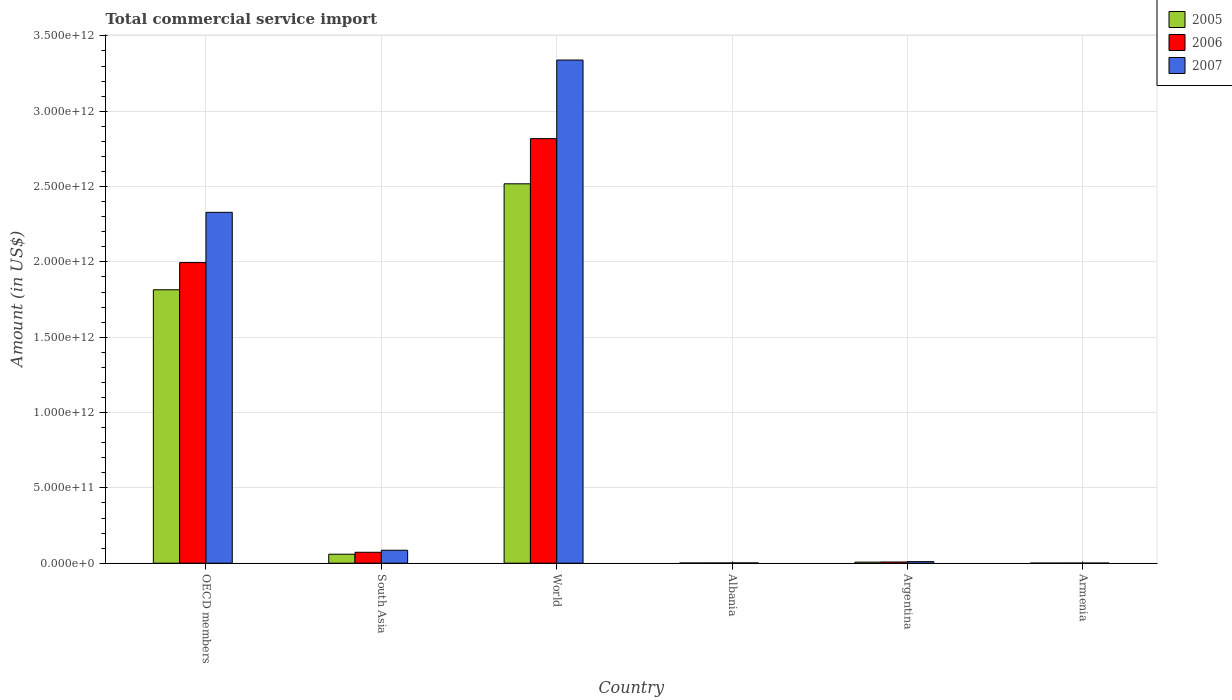How many different coloured bars are there?
Your answer should be compact. 3. How many groups of bars are there?
Keep it short and to the point. 6. Are the number of bars on each tick of the X-axis equal?
Provide a succinct answer. Yes. How many bars are there on the 1st tick from the left?
Provide a succinct answer. 3. How many bars are there on the 1st tick from the right?
Offer a very short reply. 3. What is the label of the 3rd group of bars from the left?
Make the answer very short. World. What is the total commercial service import in 2005 in South Asia?
Provide a succinct answer. 5.96e+1. Across all countries, what is the maximum total commercial service import in 2005?
Provide a succinct answer. 2.52e+12. Across all countries, what is the minimum total commercial service import in 2007?
Offer a very short reply. 8.64e+08. In which country was the total commercial service import in 2005 maximum?
Ensure brevity in your answer.  World. In which country was the total commercial service import in 2005 minimum?
Provide a succinct answer. Armenia. What is the total total commercial service import in 2006 in the graph?
Provide a short and direct response. 4.90e+12. What is the difference between the total commercial service import in 2006 in Albania and that in World?
Provide a succinct answer. -2.82e+12. What is the difference between the total commercial service import in 2005 in OECD members and the total commercial service import in 2007 in South Asia?
Offer a very short reply. 1.73e+12. What is the average total commercial service import in 2007 per country?
Your response must be concise. 9.61e+11. What is the difference between the total commercial service import of/in 2006 and total commercial service import of/in 2005 in World?
Offer a very short reply. 3.00e+11. In how many countries, is the total commercial service import in 2005 greater than 2000000000000 US$?
Your answer should be very brief. 1. What is the ratio of the total commercial service import in 2007 in Argentina to that in South Asia?
Make the answer very short. 0.12. Is the total commercial service import in 2005 in Argentina less than that in OECD members?
Offer a very short reply. Yes. Is the difference between the total commercial service import in 2006 in Albania and World greater than the difference between the total commercial service import in 2005 in Albania and World?
Offer a very short reply. No. What is the difference between the highest and the second highest total commercial service import in 2005?
Keep it short and to the point. -7.03e+11. What is the difference between the highest and the lowest total commercial service import in 2005?
Your answer should be very brief. 2.52e+12. In how many countries, is the total commercial service import in 2006 greater than the average total commercial service import in 2006 taken over all countries?
Your answer should be very brief. 2. Is the sum of the total commercial service import in 2007 in Albania and South Asia greater than the maximum total commercial service import in 2006 across all countries?
Make the answer very short. No. What does the 1st bar from the right in OECD members represents?
Provide a succinct answer. 2007. Is it the case that in every country, the sum of the total commercial service import in 2007 and total commercial service import in 2005 is greater than the total commercial service import in 2006?
Offer a terse response. Yes. Are all the bars in the graph horizontal?
Offer a terse response. No. What is the difference between two consecutive major ticks on the Y-axis?
Your answer should be compact. 5.00e+11. Are the values on the major ticks of Y-axis written in scientific E-notation?
Your answer should be compact. Yes. Does the graph contain any zero values?
Your answer should be compact. No. Where does the legend appear in the graph?
Make the answer very short. Top right. How are the legend labels stacked?
Your response must be concise. Vertical. What is the title of the graph?
Offer a terse response. Total commercial service import. What is the label or title of the Y-axis?
Offer a terse response. Amount (in US$). What is the Amount (in US$) in 2005 in OECD members?
Offer a very short reply. 1.81e+12. What is the Amount (in US$) in 2006 in OECD members?
Your answer should be compact. 2.00e+12. What is the Amount (in US$) of 2007 in OECD members?
Ensure brevity in your answer.  2.33e+12. What is the Amount (in US$) of 2005 in South Asia?
Keep it short and to the point. 5.96e+1. What is the Amount (in US$) of 2006 in South Asia?
Give a very brief answer. 7.25e+1. What is the Amount (in US$) of 2007 in South Asia?
Your answer should be compact. 8.60e+1. What is the Amount (in US$) in 2005 in World?
Offer a terse response. 2.52e+12. What is the Amount (in US$) in 2006 in World?
Give a very brief answer. 2.82e+12. What is the Amount (in US$) in 2007 in World?
Your response must be concise. 3.34e+12. What is the Amount (in US$) of 2005 in Albania?
Give a very brief answer. 1.32e+09. What is the Amount (in US$) of 2006 in Albania?
Provide a succinct answer. 1.54e+09. What is the Amount (in US$) of 2007 in Albania?
Your answer should be compact. 1.89e+09. What is the Amount (in US$) of 2005 in Argentina?
Offer a very short reply. 7.24e+09. What is the Amount (in US$) of 2006 in Argentina?
Your response must be concise. 8.10e+09. What is the Amount (in US$) in 2007 in Argentina?
Offer a very short reply. 1.04e+1. What is the Amount (in US$) in 2005 in Armenia?
Ensure brevity in your answer.  5.61e+08. What is the Amount (in US$) of 2006 in Armenia?
Give a very brief answer. 6.62e+08. What is the Amount (in US$) of 2007 in Armenia?
Give a very brief answer. 8.64e+08. Across all countries, what is the maximum Amount (in US$) of 2005?
Your answer should be very brief. 2.52e+12. Across all countries, what is the maximum Amount (in US$) in 2006?
Ensure brevity in your answer.  2.82e+12. Across all countries, what is the maximum Amount (in US$) of 2007?
Give a very brief answer. 3.34e+12. Across all countries, what is the minimum Amount (in US$) in 2005?
Your response must be concise. 5.61e+08. Across all countries, what is the minimum Amount (in US$) in 2006?
Offer a terse response. 6.62e+08. Across all countries, what is the minimum Amount (in US$) in 2007?
Ensure brevity in your answer.  8.64e+08. What is the total Amount (in US$) in 2005 in the graph?
Your response must be concise. 4.40e+12. What is the total Amount (in US$) in 2006 in the graph?
Your answer should be compact. 4.90e+12. What is the total Amount (in US$) in 2007 in the graph?
Offer a very short reply. 5.77e+12. What is the difference between the Amount (in US$) in 2005 in OECD members and that in South Asia?
Ensure brevity in your answer.  1.76e+12. What is the difference between the Amount (in US$) of 2006 in OECD members and that in South Asia?
Make the answer very short. 1.92e+12. What is the difference between the Amount (in US$) in 2007 in OECD members and that in South Asia?
Give a very brief answer. 2.24e+12. What is the difference between the Amount (in US$) of 2005 in OECD members and that in World?
Provide a succinct answer. -7.03e+11. What is the difference between the Amount (in US$) of 2006 in OECD members and that in World?
Ensure brevity in your answer.  -8.23e+11. What is the difference between the Amount (in US$) in 2007 in OECD members and that in World?
Your response must be concise. -1.01e+12. What is the difference between the Amount (in US$) of 2005 in OECD members and that in Albania?
Offer a very short reply. 1.81e+12. What is the difference between the Amount (in US$) of 2006 in OECD members and that in Albania?
Give a very brief answer. 1.99e+12. What is the difference between the Amount (in US$) of 2007 in OECD members and that in Albania?
Provide a short and direct response. 2.33e+12. What is the difference between the Amount (in US$) of 2005 in OECD members and that in Argentina?
Offer a very short reply. 1.81e+12. What is the difference between the Amount (in US$) of 2006 in OECD members and that in Argentina?
Your response must be concise. 1.99e+12. What is the difference between the Amount (in US$) of 2007 in OECD members and that in Argentina?
Provide a succinct answer. 2.32e+12. What is the difference between the Amount (in US$) in 2005 in OECD members and that in Armenia?
Your answer should be compact. 1.81e+12. What is the difference between the Amount (in US$) in 2006 in OECD members and that in Armenia?
Provide a short and direct response. 1.99e+12. What is the difference between the Amount (in US$) in 2007 in OECD members and that in Armenia?
Your answer should be very brief. 2.33e+12. What is the difference between the Amount (in US$) of 2005 in South Asia and that in World?
Offer a terse response. -2.46e+12. What is the difference between the Amount (in US$) of 2006 in South Asia and that in World?
Your response must be concise. -2.75e+12. What is the difference between the Amount (in US$) in 2007 in South Asia and that in World?
Your answer should be very brief. -3.25e+12. What is the difference between the Amount (in US$) of 2005 in South Asia and that in Albania?
Offer a very short reply. 5.83e+1. What is the difference between the Amount (in US$) of 2006 in South Asia and that in Albania?
Make the answer very short. 7.10e+1. What is the difference between the Amount (in US$) in 2007 in South Asia and that in Albania?
Offer a terse response. 8.41e+1. What is the difference between the Amount (in US$) of 2005 in South Asia and that in Argentina?
Keep it short and to the point. 5.24e+1. What is the difference between the Amount (in US$) in 2006 in South Asia and that in Argentina?
Give a very brief answer. 6.44e+1. What is the difference between the Amount (in US$) of 2007 in South Asia and that in Argentina?
Offer a terse response. 7.56e+1. What is the difference between the Amount (in US$) in 2005 in South Asia and that in Armenia?
Your answer should be very brief. 5.91e+1. What is the difference between the Amount (in US$) in 2006 in South Asia and that in Armenia?
Your response must be concise. 7.19e+1. What is the difference between the Amount (in US$) in 2007 in South Asia and that in Armenia?
Your answer should be very brief. 8.51e+1. What is the difference between the Amount (in US$) of 2005 in World and that in Albania?
Keep it short and to the point. 2.52e+12. What is the difference between the Amount (in US$) in 2006 in World and that in Albania?
Make the answer very short. 2.82e+12. What is the difference between the Amount (in US$) in 2007 in World and that in Albania?
Make the answer very short. 3.34e+12. What is the difference between the Amount (in US$) in 2005 in World and that in Argentina?
Make the answer very short. 2.51e+12. What is the difference between the Amount (in US$) in 2006 in World and that in Argentina?
Give a very brief answer. 2.81e+12. What is the difference between the Amount (in US$) of 2007 in World and that in Argentina?
Ensure brevity in your answer.  3.33e+12. What is the difference between the Amount (in US$) in 2005 in World and that in Armenia?
Ensure brevity in your answer.  2.52e+12. What is the difference between the Amount (in US$) of 2006 in World and that in Armenia?
Your answer should be compact. 2.82e+12. What is the difference between the Amount (in US$) in 2007 in World and that in Armenia?
Keep it short and to the point. 3.34e+12. What is the difference between the Amount (in US$) of 2005 in Albania and that in Argentina?
Offer a terse response. -5.92e+09. What is the difference between the Amount (in US$) of 2006 in Albania and that in Argentina?
Your answer should be compact. -6.56e+09. What is the difference between the Amount (in US$) of 2007 in Albania and that in Argentina?
Ensure brevity in your answer.  -8.50e+09. What is the difference between the Amount (in US$) in 2005 in Albania and that in Armenia?
Give a very brief answer. 7.56e+08. What is the difference between the Amount (in US$) in 2006 in Albania and that in Armenia?
Keep it short and to the point. 8.79e+08. What is the difference between the Amount (in US$) in 2007 in Albania and that in Armenia?
Ensure brevity in your answer.  1.03e+09. What is the difference between the Amount (in US$) of 2005 in Argentina and that in Armenia?
Offer a very short reply. 6.67e+09. What is the difference between the Amount (in US$) in 2006 in Argentina and that in Armenia?
Your response must be concise. 7.44e+09. What is the difference between the Amount (in US$) in 2007 in Argentina and that in Armenia?
Your response must be concise. 9.53e+09. What is the difference between the Amount (in US$) in 2005 in OECD members and the Amount (in US$) in 2006 in South Asia?
Your response must be concise. 1.74e+12. What is the difference between the Amount (in US$) of 2005 in OECD members and the Amount (in US$) of 2007 in South Asia?
Offer a very short reply. 1.73e+12. What is the difference between the Amount (in US$) of 2006 in OECD members and the Amount (in US$) of 2007 in South Asia?
Your answer should be very brief. 1.91e+12. What is the difference between the Amount (in US$) of 2005 in OECD members and the Amount (in US$) of 2006 in World?
Give a very brief answer. -1.00e+12. What is the difference between the Amount (in US$) of 2005 in OECD members and the Amount (in US$) of 2007 in World?
Keep it short and to the point. -1.52e+12. What is the difference between the Amount (in US$) of 2006 in OECD members and the Amount (in US$) of 2007 in World?
Provide a succinct answer. -1.34e+12. What is the difference between the Amount (in US$) in 2005 in OECD members and the Amount (in US$) in 2006 in Albania?
Your response must be concise. 1.81e+12. What is the difference between the Amount (in US$) in 2005 in OECD members and the Amount (in US$) in 2007 in Albania?
Your response must be concise. 1.81e+12. What is the difference between the Amount (in US$) of 2006 in OECD members and the Amount (in US$) of 2007 in Albania?
Give a very brief answer. 1.99e+12. What is the difference between the Amount (in US$) in 2005 in OECD members and the Amount (in US$) in 2006 in Argentina?
Your response must be concise. 1.81e+12. What is the difference between the Amount (in US$) of 2005 in OECD members and the Amount (in US$) of 2007 in Argentina?
Offer a very short reply. 1.80e+12. What is the difference between the Amount (in US$) in 2006 in OECD members and the Amount (in US$) in 2007 in Argentina?
Your response must be concise. 1.99e+12. What is the difference between the Amount (in US$) of 2005 in OECD members and the Amount (in US$) of 2006 in Armenia?
Your answer should be compact. 1.81e+12. What is the difference between the Amount (in US$) in 2005 in OECD members and the Amount (in US$) in 2007 in Armenia?
Provide a succinct answer. 1.81e+12. What is the difference between the Amount (in US$) in 2006 in OECD members and the Amount (in US$) in 2007 in Armenia?
Offer a very short reply. 1.99e+12. What is the difference between the Amount (in US$) of 2005 in South Asia and the Amount (in US$) of 2006 in World?
Make the answer very short. -2.76e+12. What is the difference between the Amount (in US$) of 2005 in South Asia and the Amount (in US$) of 2007 in World?
Offer a terse response. -3.28e+12. What is the difference between the Amount (in US$) of 2006 in South Asia and the Amount (in US$) of 2007 in World?
Offer a terse response. -3.27e+12. What is the difference between the Amount (in US$) in 2005 in South Asia and the Amount (in US$) in 2006 in Albania?
Keep it short and to the point. 5.81e+1. What is the difference between the Amount (in US$) in 2005 in South Asia and the Amount (in US$) in 2007 in Albania?
Ensure brevity in your answer.  5.77e+1. What is the difference between the Amount (in US$) of 2006 in South Asia and the Amount (in US$) of 2007 in Albania?
Keep it short and to the point. 7.06e+1. What is the difference between the Amount (in US$) in 2005 in South Asia and the Amount (in US$) in 2006 in Argentina?
Your answer should be compact. 5.15e+1. What is the difference between the Amount (in US$) of 2005 in South Asia and the Amount (in US$) of 2007 in Argentina?
Ensure brevity in your answer.  4.92e+1. What is the difference between the Amount (in US$) in 2006 in South Asia and the Amount (in US$) in 2007 in Argentina?
Give a very brief answer. 6.21e+1. What is the difference between the Amount (in US$) in 2005 in South Asia and the Amount (in US$) in 2006 in Armenia?
Your response must be concise. 5.90e+1. What is the difference between the Amount (in US$) of 2005 in South Asia and the Amount (in US$) of 2007 in Armenia?
Provide a succinct answer. 5.88e+1. What is the difference between the Amount (in US$) of 2006 in South Asia and the Amount (in US$) of 2007 in Armenia?
Provide a short and direct response. 7.17e+1. What is the difference between the Amount (in US$) of 2005 in World and the Amount (in US$) of 2006 in Albania?
Offer a terse response. 2.52e+12. What is the difference between the Amount (in US$) of 2005 in World and the Amount (in US$) of 2007 in Albania?
Your answer should be very brief. 2.52e+12. What is the difference between the Amount (in US$) of 2006 in World and the Amount (in US$) of 2007 in Albania?
Your answer should be compact. 2.82e+12. What is the difference between the Amount (in US$) of 2005 in World and the Amount (in US$) of 2006 in Argentina?
Keep it short and to the point. 2.51e+12. What is the difference between the Amount (in US$) of 2005 in World and the Amount (in US$) of 2007 in Argentina?
Give a very brief answer. 2.51e+12. What is the difference between the Amount (in US$) of 2006 in World and the Amount (in US$) of 2007 in Argentina?
Give a very brief answer. 2.81e+12. What is the difference between the Amount (in US$) of 2005 in World and the Amount (in US$) of 2006 in Armenia?
Provide a succinct answer. 2.52e+12. What is the difference between the Amount (in US$) of 2005 in World and the Amount (in US$) of 2007 in Armenia?
Your answer should be very brief. 2.52e+12. What is the difference between the Amount (in US$) of 2006 in World and the Amount (in US$) of 2007 in Armenia?
Provide a short and direct response. 2.82e+12. What is the difference between the Amount (in US$) of 2005 in Albania and the Amount (in US$) of 2006 in Argentina?
Provide a succinct answer. -6.79e+09. What is the difference between the Amount (in US$) of 2005 in Albania and the Amount (in US$) of 2007 in Argentina?
Make the answer very short. -9.08e+09. What is the difference between the Amount (in US$) in 2006 in Albania and the Amount (in US$) in 2007 in Argentina?
Provide a succinct answer. -8.85e+09. What is the difference between the Amount (in US$) in 2005 in Albania and the Amount (in US$) in 2006 in Armenia?
Offer a terse response. 6.55e+08. What is the difference between the Amount (in US$) of 2005 in Albania and the Amount (in US$) of 2007 in Armenia?
Your answer should be very brief. 4.53e+08. What is the difference between the Amount (in US$) of 2006 in Albania and the Amount (in US$) of 2007 in Armenia?
Ensure brevity in your answer.  6.76e+08. What is the difference between the Amount (in US$) of 2005 in Argentina and the Amount (in US$) of 2006 in Armenia?
Provide a short and direct response. 6.57e+09. What is the difference between the Amount (in US$) of 2005 in Argentina and the Amount (in US$) of 2007 in Armenia?
Your answer should be compact. 6.37e+09. What is the difference between the Amount (in US$) in 2006 in Argentina and the Amount (in US$) in 2007 in Armenia?
Ensure brevity in your answer.  7.24e+09. What is the average Amount (in US$) of 2005 per country?
Make the answer very short. 7.34e+11. What is the average Amount (in US$) in 2006 per country?
Offer a very short reply. 8.16e+11. What is the average Amount (in US$) of 2007 per country?
Give a very brief answer. 9.61e+11. What is the difference between the Amount (in US$) of 2005 and Amount (in US$) of 2006 in OECD members?
Make the answer very short. -1.80e+11. What is the difference between the Amount (in US$) in 2005 and Amount (in US$) in 2007 in OECD members?
Keep it short and to the point. -5.14e+11. What is the difference between the Amount (in US$) of 2006 and Amount (in US$) of 2007 in OECD members?
Your answer should be very brief. -3.34e+11. What is the difference between the Amount (in US$) in 2005 and Amount (in US$) in 2006 in South Asia?
Ensure brevity in your answer.  -1.29e+1. What is the difference between the Amount (in US$) of 2005 and Amount (in US$) of 2007 in South Asia?
Offer a terse response. -2.64e+1. What is the difference between the Amount (in US$) in 2006 and Amount (in US$) in 2007 in South Asia?
Provide a short and direct response. -1.35e+1. What is the difference between the Amount (in US$) in 2005 and Amount (in US$) in 2006 in World?
Provide a short and direct response. -3.00e+11. What is the difference between the Amount (in US$) in 2005 and Amount (in US$) in 2007 in World?
Offer a very short reply. -8.22e+11. What is the difference between the Amount (in US$) of 2006 and Amount (in US$) of 2007 in World?
Offer a very short reply. -5.22e+11. What is the difference between the Amount (in US$) in 2005 and Amount (in US$) in 2006 in Albania?
Keep it short and to the point. -2.23e+08. What is the difference between the Amount (in US$) of 2005 and Amount (in US$) of 2007 in Albania?
Your answer should be very brief. -5.74e+08. What is the difference between the Amount (in US$) of 2006 and Amount (in US$) of 2007 in Albania?
Ensure brevity in your answer.  -3.51e+08. What is the difference between the Amount (in US$) of 2005 and Amount (in US$) of 2006 in Argentina?
Offer a terse response. -8.69e+08. What is the difference between the Amount (in US$) of 2005 and Amount (in US$) of 2007 in Argentina?
Your answer should be very brief. -3.16e+09. What is the difference between the Amount (in US$) of 2006 and Amount (in US$) of 2007 in Argentina?
Your answer should be compact. -2.29e+09. What is the difference between the Amount (in US$) of 2005 and Amount (in US$) of 2006 in Armenia?
Offer a terse response. -1.01e+08. What is the difference between the Amount (in US$) of 2005 and Amount (in US$) of 2007 in Armenia?
Provide a succinct answer. -3.03e+08. What is the difference between the Amount (in US$) of 2006 and Amount (in US$) of 2007 in Armenia?
Provide a succinct answer. -2.02e+08. What is the ratio of the Amount (in US$) of 2005 in OECD members to that in South Asia?
Offer a very short reply. 30.43. What is the ratio of the Amount (in US$) of 2006 in OECD members to that in South Asia?
Offer a terse response. 27.52. What is the ratio of the Amount (in US$) of 2007 in OECD members to that in South Asia?
Make the answer very short. 27.08. What is the ratio of the Amount (in US$) in 2005 in OECD members to that in World?
Provide a succinct answer. 0.72. What is the ratio of the Amount (in US$) in 2006 in OECD members to that in World?
Offer a very short reply. 0.71. What is the ratio of the Amount (in US$) of 2007 in OECD members to that in World?
Offer a very short reply. 0.7. What is the ratio of the Amount (in US$) of 2005 in OECD members to that in Albania?
Give a very brief answer. 1377.35. What is the ratio of the Amount (in US$) in 2006 in OECD members to that in Albania?
Offer a terse response. 1295.07. What is the ratio of the Amount (in US$) in 2007 in OECD members to that in Albania?
Your answer should be compact. 1231.06. What is the ratio of the Amount (in US$) of 2005 in OECD members to that in Argentina?
Your answer should be compact. 250.85. What is the ratio of the Amount (in US$) in 2006 in OECD members to that in Argentina?
Your response must be concise. 246.21. What is the ratio of the Amount (in US$) in 2007 in OECD members to that in Argentina?
Offer a terse response. 224.04. What is the ratio of the Amount (in US$) of 2005 in OECD members to that in Armenia?
Offer a terse response. 3233.05. What is the ratio of the Amount (in US$) of 2006 in OECD members to that in Armenia?
Provide a succinct answer. 3013.13. What is the ratio of the Amount (in US$) in 2007 in OECD members to that in Armenia?
Your answer should be compact. 2694.22. What is the ratio of the Amount (in US$) of 2005 in South Asia to that in World?
Give a very brief answer. 0.02. What is the ratio of the Amount (in US$) of 2006 in South Asia to that in World?
Your answer should be compact. 0.03. What is the ratio of the Amount (in US$) in 2007 in South Asia to that in World?
Provide a succinct answer. 0.03. What is the ratio of the Amount (in US$) in 2005 in South Asia to that in Albania?
Ensure brevity in your answer.  45.26. What is the ratio of the Amount (in US$) in 2006 in South Asia to that in Albania?
Provide a succinct answer. 47.07. What is the ratio of the Amount (in US$) in 2007 in South Asia to that in Albania?
Your answer should be very brief. 45.47. What is the ratio of the Amount (in US$) in 2005 in South Asia to that in Argentina?
Give a very brief answer. 8.24. What is the ratio of the Amount (in US$) in 2006 in South Asia to that in Argentina?
Give a very brief answer. 8.95. What is the ratio of the Amount (in US$) of 2007 in South Asia to that in Argentina?
Make the answer very short. 8.27. What is the ratio of the Amount (in US$) of 2005 in South Asia to that in Armenia?
Your answer should be very brief. 106.24. What is the ratio of the Amount (in US$) in 2006 in South Asia to that in Armenia?
Ensure brevity in your answer.  109.5. What is the ratio of the Amount (in US$) in 2007 in South Asia to that in Armenia?
Give a very brief answer. 99.5. What is the ratio of the Amount (in US$) of 2005 in World to that in Albania?
Your answer should be compact. 1911.13. What is the ratio of the Amount (in US$) in 2006 in World to that in Albania?
Your response must be concise. 1829.02. What is the ratio of the Amount (in US$) in 2007 in World to that in Albania?
Provide a succinct answer. 1765.41. What is the ratio of the Amount (in US$) in 2005 in World to that in Argentina?
Give a very brief answer. 348.07. What is the ratio of the Amount (in US$) of 2006 in World to that in Argentina?
Your response must be concise. 347.72. What is the ratio of the Amount (in US$) of 2007 in World to that in Argentina?
Your answer should be very brief. 321.29. What is the ratio of the Amount (in US$) in 2005 in World to that in Armenia?
Offer a very short reply. 4485.98. What is the ratio of the Amount (in US$) in 2006 in World to that in Armenia?
Offer a very short reply. 4255.42. What is the ratio of the Amount (in US$) of 2007 in World to that in Armenia?
Offer a terse response. 3863.67. What is the ratio of the Amount (in US$) of 2005 in Albania to that in Argentina?
Give a very brief answer. 0.18. What is the ratio of the Amount (in US$) of 2006 in Albania to that in Argentina?
Keep it short and to the point. 0.19. What is the ratio of the Amount (in US$) in 2007 in Albania to that in Argentina?
Offer a terse response. 0.18. What is the ratio of the Amount (in US$) in 2005 in Albania to that in Armenia?
Your answer should be very brief. 2.35. What is the ratio of the Amount (in US$) in 2006 in Albania to that in Armenia?
Give a very brief answer. 2.33. What is the ratio of the Amount (in US$) of 2007 in Albania to that in Armenia?
Your answer should be very brief. 2.19. What is the ratio of the Amount (in US$) in 2005 in Argentina to that in Armenia?
Make the answer very short. 12.89. What is the ratio of the Amount (in US$) in 2006 in Argentina to that in Armenia?
Your response must be concise. 12.24. What is the ratio of the Amount (in US$) in 2007 in Argentina to that in Armenia?
Keep it short and to the point. 12.03. What is the difference between the highest and the second highest Amount (in US$) in 2005?
Provide a succinct answer. 7.03e+11. What is the difference between the highest and the second highest Amount (in US$) in 2006?
Your answer should be compact. 8.23e+11. What is the difference between the highest and the second highest Amount (in US$) in 2007?
Offer a very short reply. 1.01e+12. What is the difference between the highest and the lowest Amount (in US$) of 2005?
Your response must be concise. 2.52e+12. What is the difference between the highest and the lowest Amount (in US$) of 2006?
Offer a terse response. 2.82e+12. What is the difference between the highest and the lowest Amount (in US$) of 2007?
Ensure brevity in your answer.  3.34e+12. 